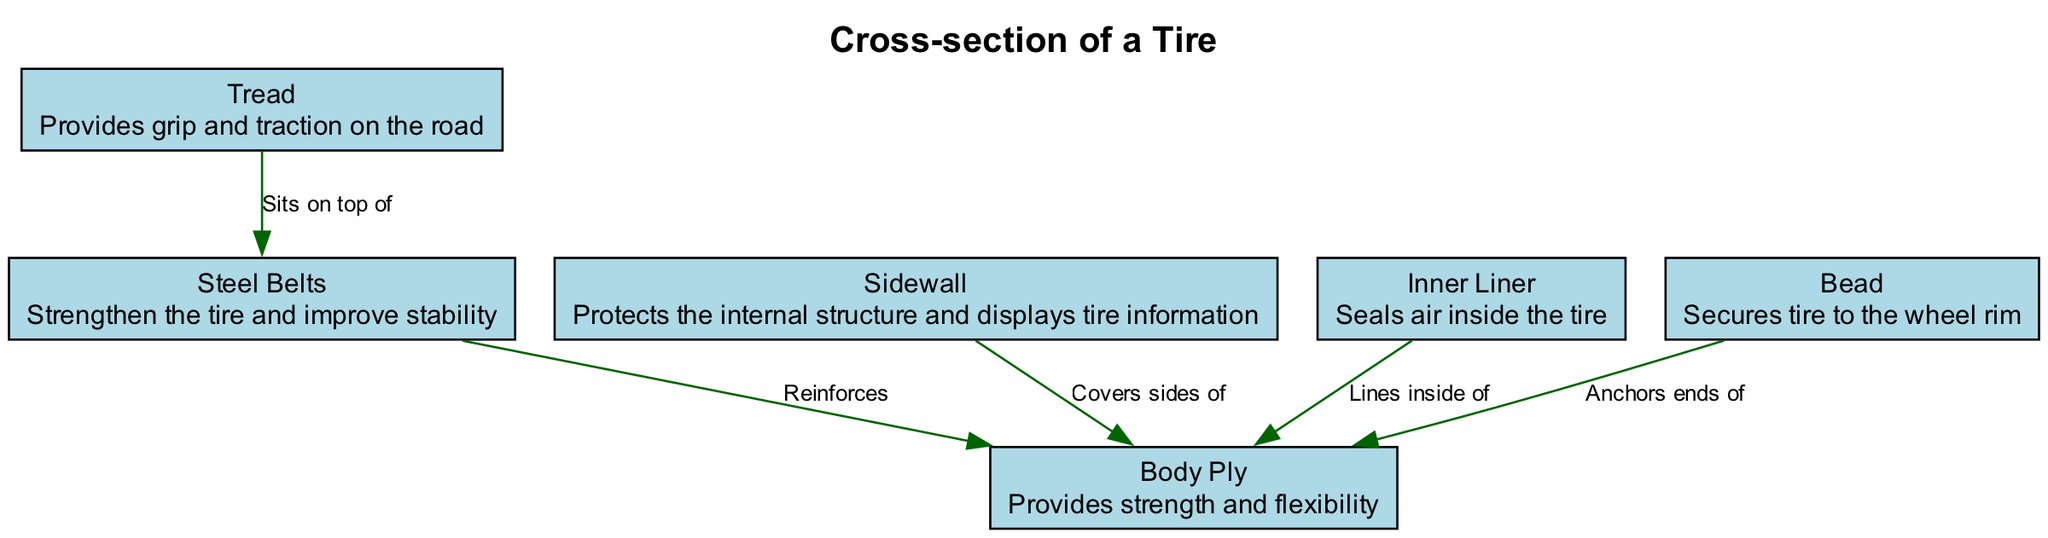What is the outermost layer of the tire? The outermost layer of the tire is labeled as "Tread," which provides grip and traction on the road. This can be identified as the first layer when looking at the cross-section from top to bottom.
Answer: Tread How many elements are labeled in the diagram? The diagram lists six distinct elements: Tread, Steel Belts, Sidewall, Inner Liner, Bead, and Body Ply. Counting the names of these elements gives the total number of elements present in the diagram.
Answer: 6 What layer provides strength and flexibility? The layer that provides strength and flexibility is called "Body Ply." This information is directly stated in the diagram's description for this specific layer.
Answer: Body Ply What does the Sidewall cover? The Sidewall covers the sides of the Body Ply. This is described in the relationship between Sidewall and Body Ply in the diagram.
Answer: Sides of Body Ply Which element secures the tire to the wheel rim? The element that secures the tire to the wheel rim is the "Bead." This is specified in the description of the Bead within the diagram.
Answer: Bead What does the Inner Liner do? The Inner Liner serves the function of sealing air inside the tire, as outlined in the description provided in the diagram.
Answer: Seals air inside the tire What is reinforced by steel belts in the tire structure? The Body Ply is reinforced by the Steel Belts, indicated by the relationship defined between these two elements in the diagram.
Answer: Body Ply How is the Tread positioned in relation to the Steel Belts? The Tread is positioned directly on top of the Steel Belts, as indicated in the relationship noted in the diagram.
Answer: Sits on top of Steel Belts What element protects the internal structure of the tire? The element that protects the internal structure of the tire is the "Sidewall," according to the information provided in its description in the diagram.
Answer: Sidewall 